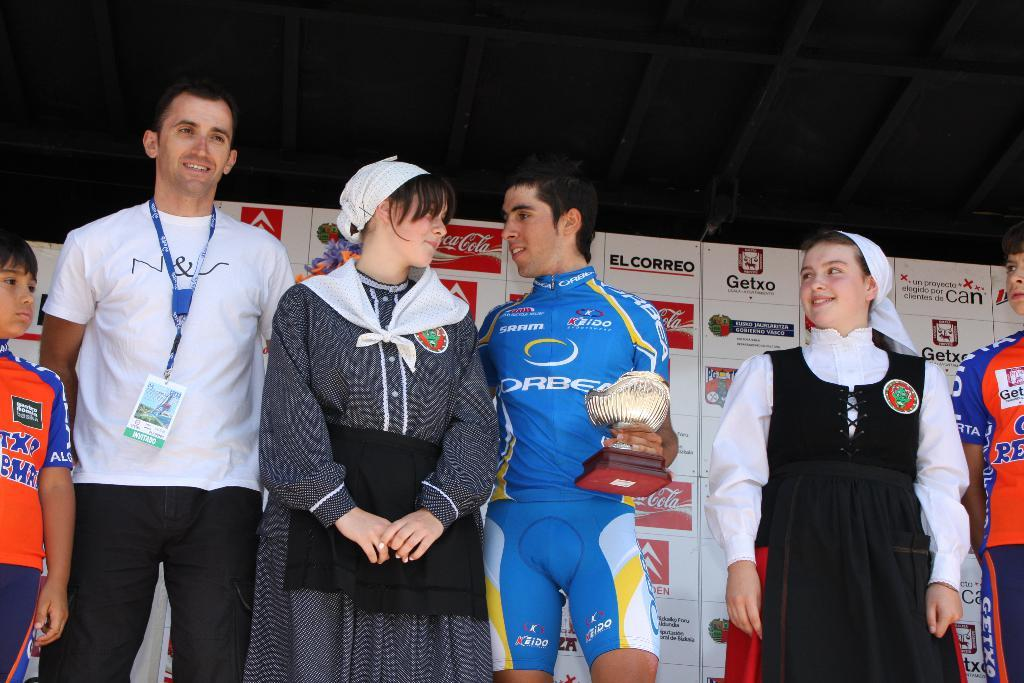<image>
Summarize the visual content of the image. a Getxo ad behind some people standing together 